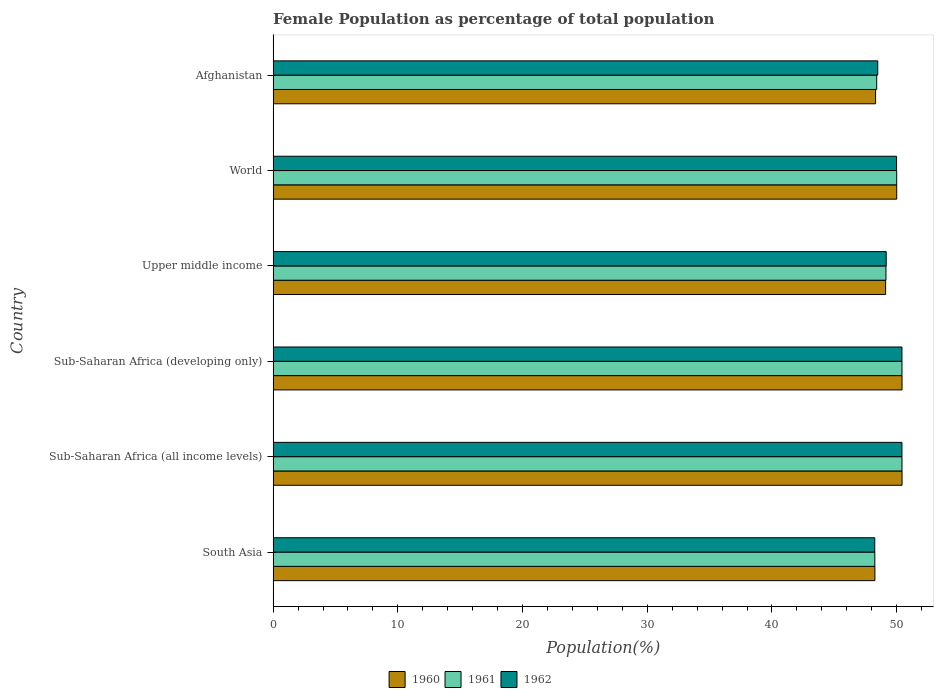How many groups of bars are there?
Offer a very short reply. 6. Are the number of bars on each tick of the Y-axis equal?
Your response must be concise. Yes. How many bars are there on the 2nd tick from the bottom?
Your response must be concise. 3. What is the label of the 1st group of bars from the top?
Keep it short and to the point. Afghanistan. What is the female population in in 1962 in Upper middle income?
Ensure brevity in your answer.  49.16. Across all countries, what is the maximum female population in in 1960?
Your response must be concise. 50.43. Across all countries, what is the minimum female population in in 1961?
Offer a very short reply. 48.25. In which country was the female population in in 1960 maximum?
Offer a terse response. Sub-Saharan Africa (all income levels). In which country was the female population in in 1962 minimum?
Your answer should be very brief. South Asia. What is the total female population in in 1961 in the graph?
Provide a short and direct response. 296.63. What is the difference between the female population in in 1960 in Sub-Saharan Africa (developing only) and that in World?
Make the answer very short. 0.43. What is the difference between the female population in in 1960 in Sub-Saharan Africa (developing only) and the female population in in 1962 in Sub-Saharan Africa (all income levels)?
Provide a succinct answer. 0.01. What is the average female population in in 1962 per country?
Your response must be concise. 49.45. What is the difference between the female population in in 1960 and female population in in 1961 in Upper middle income?
Your response must be concise. -0.03. What is the ratio of the female population in in 1961 in Sub-Saharan Africa (all income levels) to that in Sub-Saharan Africa (developing only)?
Provide a short and direct response. 1. Is the difference between the female population in in 1960 in Afghanistan and World greater than the difference between the female population in in 1961 in Afghanistan and World?
Your answer should be very brief. No. What is the difference between the highest and the second highest female population in in 1960?
Your answer should be compact. 0. What is the difference between the highest and the lowest female population in in 1961?
Offer a very short reply. 2.18. What does the 2nd bar from the top in Afghanistan represents?
Your answer should be very brief. 1961. What does the 3rd bar from the bottom in Upper middle income represents?
Offer a very short reply. 1962. Is it the case that in every country, the sum of the female population in in 1962 and female population in in 1961 is greater than the female population in in 1960?
Your answer should be compact. Yes. Are all the bars in the graph horizontal?
Keep it short and to the point. Yes. How many countries are there in the graph?
Offer a very short reply. 6. Does the graph contain any zero values?
Offer a very short reply. No. Does the graph contain grids?
Provide a succinct answer. No. Where does the legend appear in the graph?
Your answer should be compact. Bottom center. How many legend labels are there?
Your answer should be very brief. 3. What is the title of the graph?
Provide a short and direct response. Female Population as percentage of total population. Does "2008" appear as one of the legend labels in the graph?
Offer a very short reply. No. What is the label or title of the X-axis?
Offer a terse response. Population(%). What is the label or title of the Y-axis?
Make the answer very short. Country. What is the Population(%) in 1960 in South Asia?
Your response must be concise. 48.25. What is the Population(%) in 1961 in South Asia?
Make the answer very short. 48.25. What is the Population(%) of 1962 in South Asia?
Keep it short and to the point. 48.24. What is the Population(%) in 1960 in Sub-Saharan Africa (all income levels)?
Your answer should be compact. 50.43. What is the Population(%) in 1961 in Sub-Saharan Africa (all income levels)?
Make the answer very short. 50.42. What is the Population(%) in 1962 in Sub-Saharan Africa (all income levels)?
Make the answer very short. 50.42. What is the Population(%) in 1960 in Sub-Saharan Africa (developing only)?
Make the answer very short. 50.43. What is the Population(%) of 1961 in Sub-Saharan Africa (developing only)?
Give a very brief answer. 50.42. What is the Population(%) in 1962 in Sub-Saharan Africa (developing only)?
Keep it short and to the point. 50.42. What is the Population(%) in 1960 in Upper middle income?
Offer a terse response. 49.11. What is the Population(%) in 1961 in Upper middle income?
Make the answer very short. 49.14. What is the Population(%) of 1962 in Upper middle income?
Your response must be concise. 49.16. What is the Population(%) in 1960 in World?
Give a very brief answer. 50. What is the Population(%) of 1961 in World?
Your response must be concise. 50. What is the Population(%) in 1962 in World?
Offer a very short reply. 49.99. What is the Population(%) of 1960 in Afghanistan?
Ensure brevity in your answer.  48.31. What is the Population(%) of 1961 in Afghanistan?
Offer a very short reply. 48.4. What is the Population(%) of 1962 in Afghanistan?
Provide a succinct answer. 48.48. Across all countries, what is the maximum Population(%) of 1960?
Your answer should be compact. 50.43. Across all countries, what is the maximum Population(%) in 1961?
Provide a succinct answer. 50.42. Across all countries, what is the maximum Population(%) of 1962?
Your answer should be very brief. 50.42. Across all countries, what is the minimum Population(%) of 1960?
Provide a succinct answer. 48.25. Across all countries, what is the minimum Population(%) in 1961?
Offer a very short reply. 48.25. Across all countries, what is the minimum Population(%) in 1962?
Provide a succinct answer. 48.24. What is the total Population(%) of 1960 in the graph?
Offer a very short reply. 296.53. What is the total Population(%) in 1961 in the graph?
Keep it short and to the point. 296.63. What is the total Population(%) of 1962 in the graph?
Make the answer very short. 296.71. What is the difference between the Population(%) of 1960 in South Asia and that in Sub-Saharan Africa (all income levels)?
Your answer should be very brief. -2.18. What is the difference between the Population(%) in 1961 in South Asia and that in Sub-Saharan Africa (all income levels)?
Ensure brevity in your answer.  -2.18. What is the difference between the Population(%) in 1962 in South Asia and that in Sub-Saharan Africa (all income levels)?
Provide a short and direct response. -2.18. What is the difference between the Population(%) in 1960 in South Asia and that in Sub-Saharan Africa (developing only)?
Offer a very short reply. -2.18. What is the difference between the Population(%) in 1961 in South Asia and that in Sub-Saharan Africa (developing only)?
Ensure brevity in your answer.  -2.18. What is the difference between the Population(%) in 1962 in South Asia and that in Sub-Saharan Africa (developing only)?
Keep it short and to the point. -2.18. What is the difference between the Population(%) of 1960 in South Asia and that in Upper middle income?
Offer a very short reply. -0.86. What is the difference between the Population(%) in 1961 in South Asia and that in Upper middle income?
Give a very brief answer. -0.89. What is the difference between the Population(%) of 1962 in South Asia and that in Upper middle income?
Your answer should be very brief. -0.92. What is the difference between the Population(%) in 1960 in South Asia and that in World?
Your response must be concise. -1.75. What is the difference between the Population(%) in 1961 in South Asia and that in World?
Ensure brevity in your answer.  -1.75. What is the difference between the Population(%) in 1962 in South Asia and that in World?
Offer a terse response. -1.75. What is the difference between the Population(%) of 1960 in South Asia and that in Afghanistan?
Offer a terse response. -0.05. What is the difference between the Population(%) in 1961 in South Asia and that in Afghanistan?
Give a very brief answer. -0.15. What is the difference between the Population(%) in 1962 in South Asia and that in Afghanistan?
Your answer should be very brief. -0.24. What is the difference between the Population(%) in 1960 in Sub-Saharan Africa (all income levels) and that in Sub-Saharan Africa (developing only)?
Offer a very short reply. 0. What is the difference between the Population(%) of 1961 in Sub-Saharan Africa (all income levels) and that in Sub-Saharan Africa (developing only)?
Provide a succinct answer. 0. What is the difference between the Population(%) in 1962 in Sub-Saharan Africa (all income levels) and that in Sub-Saharan Africa (developing only)?
Keep it short and to the point. 0. What is the difference between the Population(%) in 1960 in Sub-Saharan Africa (all income levels) and that in Upper middle income?
Give a very brief answer. 1.32. What is the difference between the Population(%) in 1961 in Sub-Saharan Africa (all income levels) and that in Upper middle income?
Your answer should be very brief. 1.28. What is the difference between the Population(%) in 1962 in Sub-Saharan Africa (all income levels) and that in Upper middle income?
Give a very brief answer. 1.26. What is the difference between the Population(%) of 1960 in Sub-Saharan Africa (all income levels) and that in World?
Provide a succinct answer. 0.43. What is the difference between the Population(%) of 1961 in Sub-Saharan Africa (all income levels) and that in World?
Provide a succinct answer. 0.43. What is the difference between the Population(%) of 1962 in Sub-Saharan Africa (all income levels) and that in World?
Your response must be concise. 0.43. What is the difference between the Population(%) of 1960 in Sub-Saharan Africa (all income levels) and that in Afghanistan?
Ensure brevity in your answer.  2.12. What is the difference between the Population(%) of 1961 in Sub-Saharan Africa (all income levels) and that in Afghanistan?
Offer a very short reply. 2.03. What is the difference between the Population(%) of 1962 in Sub-Saharan Africa (all income levels) and that in Afghanistan?
Your answer should be very brief. 1.94. What is the difference between the Population(%) of 1960 in Sub-Saharan Africa (developing only) and that in Upper middle income?
Give a very brief answer. 1.32. What is the difference between the Population(%) of 1961 in Sub-Saharan Africa (developing only) and that in Upper middle income?
Provide a short and direct response. 1.28. What is the difference between the Population(%) in 1962 in Sub-Saharan Africa (developing only) and that in Upper middle income?
Your response must be concise. 1.26. What is the difference between the Population(%) of 1960 in Sub-Saharan Africa (developing only) and that in World?
Provide a short and direct response. 0.43. What is the difference between the Population(%) in 1961 in Sub-Saharan Africa (developing only) and that in World?
Your response must be concise. 0.42. What is the difference between the Population(%) in 1962 in Sub-Saharan Africa (developing only) and that in World?
Your response must be concise. 0.43. What is the difference between the Population(%) in 1960 in Sub-Saharan Africa (developing only) and that in Afghanistan?
Your answer should be very brief. 2.12. What is the difference between the Population(%) in 1961 in Sub-Saharan Africa (developing only) and that in Afghanistan?
Give a very brief answer. 2.03. What is the difference between the Population(%) in 1962 in Sub-Saharan Africa (developing only) and that in Afghanistan?
Keep it short and to the point. 1.94. What is the difference between the Population(%) in 1960 in Upper middle income and that in World?
Your answer should be very brief. -0.89. What is the difference between the Population(%) of 1961 in Upper middle income and that in World?
Provide a succinct answer. -0.86. What is the difference between the Population(%) in 1962 in Upper middle income and that in World?
Give a very brief answer. -0.83. What is the difference between the Population(%) of 1960 in Upper middle income and that in Afghanistan?
Give a very brief answer. 0.81. What is the difference between the Population(%) of 1961 in Upper middle income and that in Afghanistan?
Offer a very short reply. 0.74. What is the difference between the Population(%) of 1962 in Upper middle income and that in Afghanistan?
Provide a short and direct response. 0.68. What is the difference between the Population(%) of 1960 in World and that in Afghanistan?
Provide a succinct answer. 1.7. What is the difference between the Population(%) in 1961 in World and that in Afghanistan?
Offer a terse response. 1.6. What is the difference between the Population(%) of 1962 in World and that in Afghanistan?
Provide a short and direct response. 1.51. What is the difference between the Population(%) in 1960 in South Asia and the Population(%) in 1961 in Sub-Saharan Africa (all income levels)?
Your answer should be very brief. -2.17. What is the difference between the Population(%) in 1960 in South Asia and the Population(%) in 1962 in Sub-Saharan Africa (all income levels)?
Provide a short and direct response. -2.17. What is the difference between the Population(%) in 1961 in South Asia and the Population(%) in 1962 in Sub-Saharan Africa (all income levels)?
Offer a very short reply. -2.18. What is the difference between the Population(%) of 1960 in South Asia and the Population(%) of 1961 in Sub-Saharan Africa (developing only)?
Provide a short and direct response. -2.17. What is the difference between the Population(%) of 1960 in South Asia and the Population(%) of 1962 in Sub-Saharan Africa (developing only)?
Your answer should be very brief. -2.17. What is the difference between the Population(%) in 1961 in South Asia and the Population(%) in 1962 in Sub-Saharan Africa (developing only)?
Provide a succinct answer. -2.17. What is the difference between the Population(%) of 1960 in South Asia and the Population(%) of 1961 in Upper middle income?
Offer a very short reply. -0.89. What is the difference between the Population(%) in 1960 in South Asia and the Population(%) in 1962 in Upper middle income?
Give a very brief answer. -0.91. What is the difference between the Population(%) in 1961 in South Asia and the Population(%) in 1962 in Upper middle income?
Provide a short and direct response. -0.91. What is the difference between the Population(%) of 1960 in South Asia and the Population(%) of 1961 in World?
Your answer should be very brief. -1.75. What is the difference between the Population(%) in 1960 in South Asia and the Population(%) in 1962 in World?
Ensure brevity in your answer.  -1.74. What is the difference between the Population(%) in 1961 in South Asia and the Population(%) in 1962 in World?
Your answer should be compact. -1.74. What is the difference between the Population(%) in 1960 in South Asia and the Population(%) in 1961 in Afghanistan?
Offer a terse response. -0.14. What is the difference between the Population(%) in 1960 in South Asia and the Population(%) in 1962 in Afghanistan?
Make the answer very short. -0.23. What is the difference between the Population(%) in 1961 in South Asia and the Population(%) in 1962 in Afghanistan?
Ensure brevity in your answer.  -0.23. What is the difference between the Population(%) of 1960 in Sub-Saharan Africa (all income levels) and the Population(%) of 1961 in Sub-Saharan Africa (developing only)?
Your response must be concise. 0.01. What is the difference between the Population(%) of 1960 in Sub-Saharan Africa (all income levels) and the Population(%) of 1962 in Sub-Saharan Africa (developing only)?
Keep it short and to the point. 0.01. What is the difference between the Population(%) of 1961 in Sub-Saharan Africa (all income levels) and the Population(%) of 1962 in Sub-Saharan Africa (developing only)?
Make the answer very short. 0. What is the difference between the Population(%) of 1960 in Sub-Saharan Africa (all income levels) and the Population(%) of 1961 in Upper middle income?
Offer a very short reply. 1.29. What is the difference between the Population(%) of 1960 in Sub-Saharan Africa (all income levels) and the Population(%) of 1962 in Upper middle income?
Provide a short and direct response. 1.27. What is the difference between the Population(%) of 1961 in Sub-Saharan Africa (all income levels) and the Population(%) of 1962 in Upper middle income?
Provide a short and direct response. 1.27. What is the difference between the Population(%) in 1960 in Sub-Saharan Africa (all income levels) and the Population(%) in 1961 in World?
Make the answer very short. 0.43. What is the difference between the Population(%) of 1960 in Sub-Saharan Africa (all income levels) and the Population(%) of 1962 in World?
Keep it short and to the point. 0.44. What is the difference between the Population(%) of 1961 in Sub-Saharan Africa (all income levels) and the Population(%) of 1962 in World?
Offer a terse response. 0.44. What is the difference between the Population(%) in 1960 in Sub-Saharan Africa (all income levels) and the Population(%) in 1961 in Afghanistan?
Provide a succinct answer. 2.03. What is the difference between the Population(%) in 1960 in Sub-Saharan Africa (all income levels) and the Population(%) in 1962 in Afghanistan?
Offer a terse response. 1.95. What is the difference between the Population(%) in 1961 in Sub-Saharan Africa (all income levels) and the Population(%) in 1962 in Afghanistan?
Provide a succinct answer. 1.94. What is the difference between the Population(%) in 1960 in Sub-Saharan Africa (developing only) and the Population(%) in 1961 in Upper middle income?
Offer a very short reply. 1.29. What is the difference between the Population(%) of 1960 in Sub-Saharan Africa (developing only) and the Population(%) of 1962 in Upper middle income?
Keep it short and to the point. 1.27. What is the difference between the Population(%) of 1961 in Sub-Saharan Africa (developing only) and the Population(%) of 1962 in Upper middle income?
Provide a short and direct response. 1.27. What is the difference between the Population(%) in 1960 in Sub-Saharan Africa (developing only) and the Population(%) in 1961 in World?
Offer a very short reply. 0.43. What is the difference between the Population(%) in 1960 in Sub-Saharan Africa (developing only) and the Population(%) in 1962 in World?
Give a very brief answer. 0.44. What is the difference between the Population(%) of 1961 in Sub-Saharan Africa (developing only) and the Population(%) of 1962 in World?
Your response must be concise. 0.43. What is the difference between the Population(%) in 1960 in Sub-Saharan Africa (developing only) and the Population(%) in 1961 in Afghanistan?
Keep it short and to the point. 2.03. What is the difference between the Population(%) of 1960 in Sub-Saharan Africa (developing only) and the Population(%) of 1962 in Afghanistan?
Offer a terse response. 1.95. What is the difference between the Population(%) in 1961 in Sub-Saharan Africa (developing only) and the Population(%) in 1962 in Afghanistan?
Your answer should be very brief. 1.94. What is the difference between the Population(%) of 1960 in Upper middle income and the Population(%) of 1961 in World?
Your answer should be compact. -0.89. What is the difference between the Population(%) of 1960 in Upper middle income and the Population(%) of 1962 in World?
Offer a terse response. -0.88. What is the difference between the Population(%) of 1961 in Upper middle income and the Population(%) of 1962 in World?
Your answer should be very brief. -0.85. What is the difference between the Population(%) of 1960 in Upper middle income and the Population(%) of 1961 in Afghanistan?
Your response must be concise. 0.71. What is the difference between the Population(%) in 1960 in Upper middle income and the Population(%) in 1962 in Afghanistan?
Offer a terse response. 0.63. What is the difference between the Population(%) in 1961 in Upper middle income and the Population(%) in 1962 in Afghanistan?
Offer a very short reply. 0.66. What is the difference between the Population(%) of 1960 in World and the Population(%) of 1961 in Afghanistan?
Provide a succinct answer. 1.61. What is the difference between the Population(%) in 1960 in World and the Population(%) in 1962 in Afghanistan?
Provide a succinct answer. 1.52. What is the difference between the Population(%) in 1961 in World and the Population(%) in 1962 in Afghanistan?
Keep it short and to the point. 1.52. What is the average Population(%) of 1960 per country?
Provide a succinct answer. 49.42. What is the average Population(%) in 1961 per country?
Keep it short and to the point. 49.44. What is the average Population(%) in 1962 per country?
Your answer should be very brief. 49.45. What is the difference between the Population(%) in 1960 and Population(%) in 1961 in South Asia?
Keep it short and to the point. 0.01. What is the difference between the Population(%) of 1960 and Population(%) of 1962 in South Asia?
Keep it short and to the point. 0.01. What is the difference between the Population(%) in 1961 and Population(%) in 1962 in South Asia?
Offer a terse response. 0. What is the difference between the Population(%) of 1960 and Population(%) of 1961 in Sub-Saharan Africa (all income levels)?
Your response must be concise. 0. What is the difference between the Population(%) of 1960 and Population(%) of 1962 in Sub-Saharan Africa (all income levels)?
Provide a short and direct response. 0.01. What is the difference between the Population(%) in 1961 and Population(%) in 1962 in Sub-Saharan Africa (all income levels)?
Keep it short and to the point. 0. What is the difference between the Population(%) of 1960 and Population(%) of 1961 in Sub-Saharan Africa (developing only)?
Your answer should be compact. 0. What is the difference between the Population(%) in 1960 and Population(%) in 1962 in Sub-Saharan Africa (developing only)?
Ensure brevity in your answer.  0.01. What is the difference between the Population(%) of 1961 and Population(%) of 1962 in Sub-Saharan Africa (developing only)?
Provide a succinct answer. 0. What is the difference between the Population(%) of 1960 and Population(%) of 1961 in Upper middle income?
Your answer should be compact. -0.03. What is the difference between the Population(%) in 1960 and Population(%) in 1962 in Upper middle income?
Provide a succinct answer. -0.05. What is the difference between the Population(%) of 1961 and Population(%) of 1962 in Upper middle income?
Offer a very short reply. -0.02. What is the difference between the Population(%) in 1960 and Population(%) in 1961 in World?
Ensure brevity in your answer.  0. What is the difference between the Population(%) of 1960 and Population(%) of 1962 in World?
Offer a terse response. 0.01. What is the difference between the Population(%) of 1961 and Population(%) of 1962 in World?
Your answer should be compact. 0.01. What is the difference between the Population(%) of 1960 and Population(%) of 1961 in Afghanistan?
Provide a short and direct response. -0.09. What is the difference between the Population(%) in 1960 and Population(%) in 1962 in Afghanistan?
Your answer should be very brief. -0.17. What is the difference between the Population(%) of 1961 and Population(%) of 1962 in Afghanistan?
Your response must be concise. -0.08. What is the ratio of the Population(%) of 1960 in South Asia to that in Sub-Saharan Africa (all income levels)?
Make the answer very short. 0.96. What is the ratio of the Population(%) of 1961 in South Asia to that in Sub-Saharan Africa (all income levels)?
Your response must be concise. 0.96. What is the ratio of the Population(%) in 1962 in South Asia to that in Sub-Saharan Africa (all income levels)?
Provide a short and direct response. 0.96. What is the ratio of the Population(%) in 1960 in South Asia to that in Sub-Saharan Africa (developing only)?
Your answer should be very brief. 0.96. What is the ratio of the Population(%) of 1961 in South Asia to that in Sub-Saharan Africa (developing only)?
Your response must be concise. 0.96. What is the ratio of the Population(%) of 1962 in South Asia to that in Sub-Saharan Africa (developing only)?
Make the answer very short. 0.96. What is the ratio of the Population(%) of 1960 in South Asia to that in Upper middle income?
Ensure brevity in your answer.  0.98. What is the ratio of the Population(%) of 1961 in South Asia to that in Upper middle income?
Give a very brief answer. 0.98. What is the ratio of the Population(%) in 1962 in South Asia to that in Upper middle income?
Provide a short and direct response. 0.98. What is the ratio of the Population(%) in 1960 in South Asia to that in World?
Offer a very short reply. 0.96. What is the ratio of the Population(%) in 1961 in South Asia to that in World?
Give a very brief answer. 0.96. What is the ratio of the Population(%) in 1962 in South Asia to that in World?
Your answer should be very brief. 0.96. What is the ratio of the Population(%) in 1960 in South Asia to that in Afghanistan?
Offer a terse response. 1. What is the ratio of the Population(%) in 1962 in South Asia to that in Afghanistan?
Give a very brief answer. 1. What is the ratio of the Population(%) of 1960 in Sub-Saharan Africa (all income levels) to that in Sub-Saharan Africa (developing only)?
Provide a short and direct response. 1. What is the ratio of the Population(%) of 1960 in Sub-Saharan Africa (all income levels) to that in Upper middle income?
Your answer should be compact. 1.03. What is the ratio of the Population(%) in 1961 in Sub-Saharan Africa (all income levels) to that in Upper middle income?
Keep it short and to the point. 1.03. What is the ratio of the Population(%) of 1962 in Sub-Saharan Africa (all income levels) to that in Upper middle income?
Provide a short and direct response. 1.03. What is the ratio of the Population(%) in 1960 in Sub-Saharan Africa (all income levels) to that in World?
Ensure brevity in your answer.  1.01. What is the ratio of the Population(%) in 1961 in Sub-Saharan Africa (all income levels) to that in World?
Keep it short and to the point. 1.01. What is the ratio of the Population(%) in 1962 in Sub-Saharan Africa (all income levels) to that in World?
Give a very brief answer. 1.01. What is the ratio of the Population(%) of 1960 in Sub-Saharan Africa (all income levels) to that in Afghanistan?
Your answer should be very brief. 1.04. What is the ratio of the Population(%) of 1961 in Sub-Saharan Africa (all income levels) to that in Afghanistan?
Ensure brevity in your answer.  1.04. What is the ratio of the Population(%) in 1962 in Sub-Saharan Africa (all income levels) to that in Afghanistan?
Your answer should be very brief. 1.04. What is the ratio of the Population(%) in 1960 in Sub-Saharan Africa (developing only) to that in Upper middle income?
Provide a short and direct response. 1.03. What is the ratio of the Population(%) in 1961 in Sub-Saharan Africa (developing only) to that in Upper middle income?
Make the answer very short. 1.03. What is the ratio of the Population(%) of 1962 in Sub-Saharan Africa (developing only) to that in Upper middle income?
Offer a very short reply. 1.03. What is the ratio of the Population(%) of 1960 in Sub-Saharan Africa (developing only) to that in World?
Your answer should be compact. 1.01. What is the ratio of the Population(%) in 1961 in Sub-Saharan Africa (developing only) to that in World?
Give a very brief answer. 1.01. What is the ratio of the Population(%) of 1962 in Sub-Saharan Africa (developing only) to that in World?
Provide a short and direct response. 1.01. What is the ratio of the Population(%) of 1960 in Sub-Saharan Africa (developing only) to that in Afghanistan?
Your answer should be compact. 1.04. What is the ratio of the Population(%) of 1961 in Sub-Saharan Africa (developing only) to that in Afghanistan?
Your answer should be compact. 1.04. What is the ratio of the Population(%) in 1960 in Upper middle income to that in World?
Provide a short and direct response. 0.98. What is the ratio of the Population(%) of 1961 in Upper middle income to that in World?
Give a very brief answer. 0.98. What is the ratio of the Population(%) of 1962 in Upper middle income to that in World?
Your response must be concise. 0.98. What is the ratio of the Population(%) in 1960 in Upper middle income to that in Afghanistan?
Give a very brief answer. 1.02. What is the ratio of the Population(%) of 1961 in Upper middle income to that in Afghanistan?
Provide a succinct answer. 1.02. What is the ratio of the Population(%) of 1962 in Upper middle income to that in Afghanistan?
Give a very brief answer. 1.01. What is the ratio of the Population(%) in 1960 in World to that in Afghanistan?
Offer a terse response. 1.04. What is the ratio of the Population(%) in 1961 in World to that in Afghanistan?
Keep it short and to the point. 1.03. What is the ratio of the Population(%) in 1962 in World to that in Afghanistan?
Your answer should be very brief. 1.03. What is the difference between the highest and the second highest Population(%) in 1960?
Offer a very short reply. 0. What is the difference between the highest and the second highest Population(%) of 1961?
Offer a very short reply. 0. What is the difference between the highest and the second highest Population(%) in 1962?
Your answer should be compact. 0. What is the difference between the highest and the lowest Population(%) in 1960?
Give a very brief answer. 2.18. What is the difference between the highest and the lowest Population(%) in 1961?
Make the answer very short. 2.18. What is the difference between the highest and the lowest Population(%) of 1962?
Make the answer very short. 2.18. 